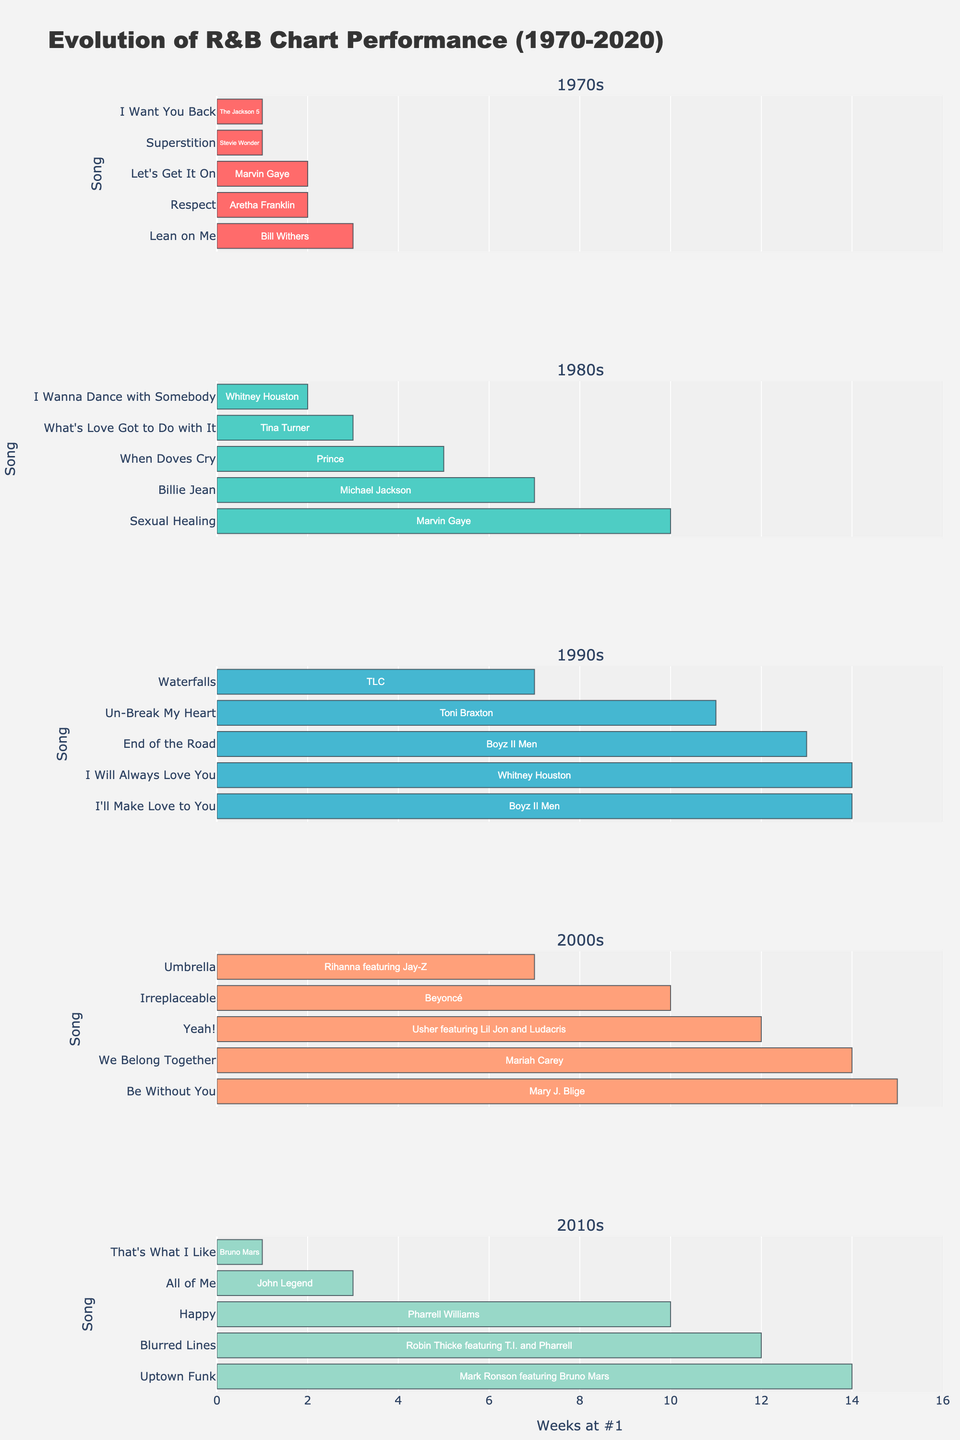What is the title of the figure? The title of the figure is displayed at the top and states "Gun Ownership Analysis Across States".
Answer: Gun Ownership Analysis Across States Which state has the highest gun ownership rate? By examining the colors on the scatter plot or the choropleth map, Montana stands out with the darkest color, indicating the highest gun ownership rate.
Answer: Montana What is the rural population percentage of Alabama? Locate Alabama in the scatter plot and check its position on the x-axis, where the value is approximately 41.0.
Answer: 41.0% Which state has the highest number of NRA members per 100k population? Refer to the height of the bars in the bar chart. Montana has the tallest bar, indicating it has the highest NRA members per 100k population.
Answer: Montana How many states have a rural population percentage higher than 40%? Count the number of data points in the scatter plot that are to the right of the 40% mark on the x-axis. Vermont, Montana, and Alabama meet this criterion.
Answer: 3 What is the combined number of hunting license holders for Texas and Wisconsin? Check the values for Texas and Wisconsin in the pie chart's data. Texas has 1,100,000 and Wisconsin has 895,000. Add these values together: 1,100,000 + 895,000 = 1,995,000.
Answer: 1,995,000 Which state has the smallest median age, and what is its gun ownership rate? By observing the size of the markers in the scatter plot, Texas seems to have the smallest median age. Its gun ownership rate, as indicated by the color, is about 45.7%.
Answer: Texas, 45.7% Compare the gun ownership rates between California and Florida, which state has a higher rate? Locate California and Florida on either the scatter plot or the choropleth map and compare their colors. Florida has a higher gun ownership rate at 32.5%, compared to California's 28.3%.
Answer: Florida What is the relationship between rural population percentage and gun ownership rate based on the scatter plot? The scatter plot shows a positive correlation; as the rural population percentage increases, so does the gun ownership rate.
Answer: Positive correlation 